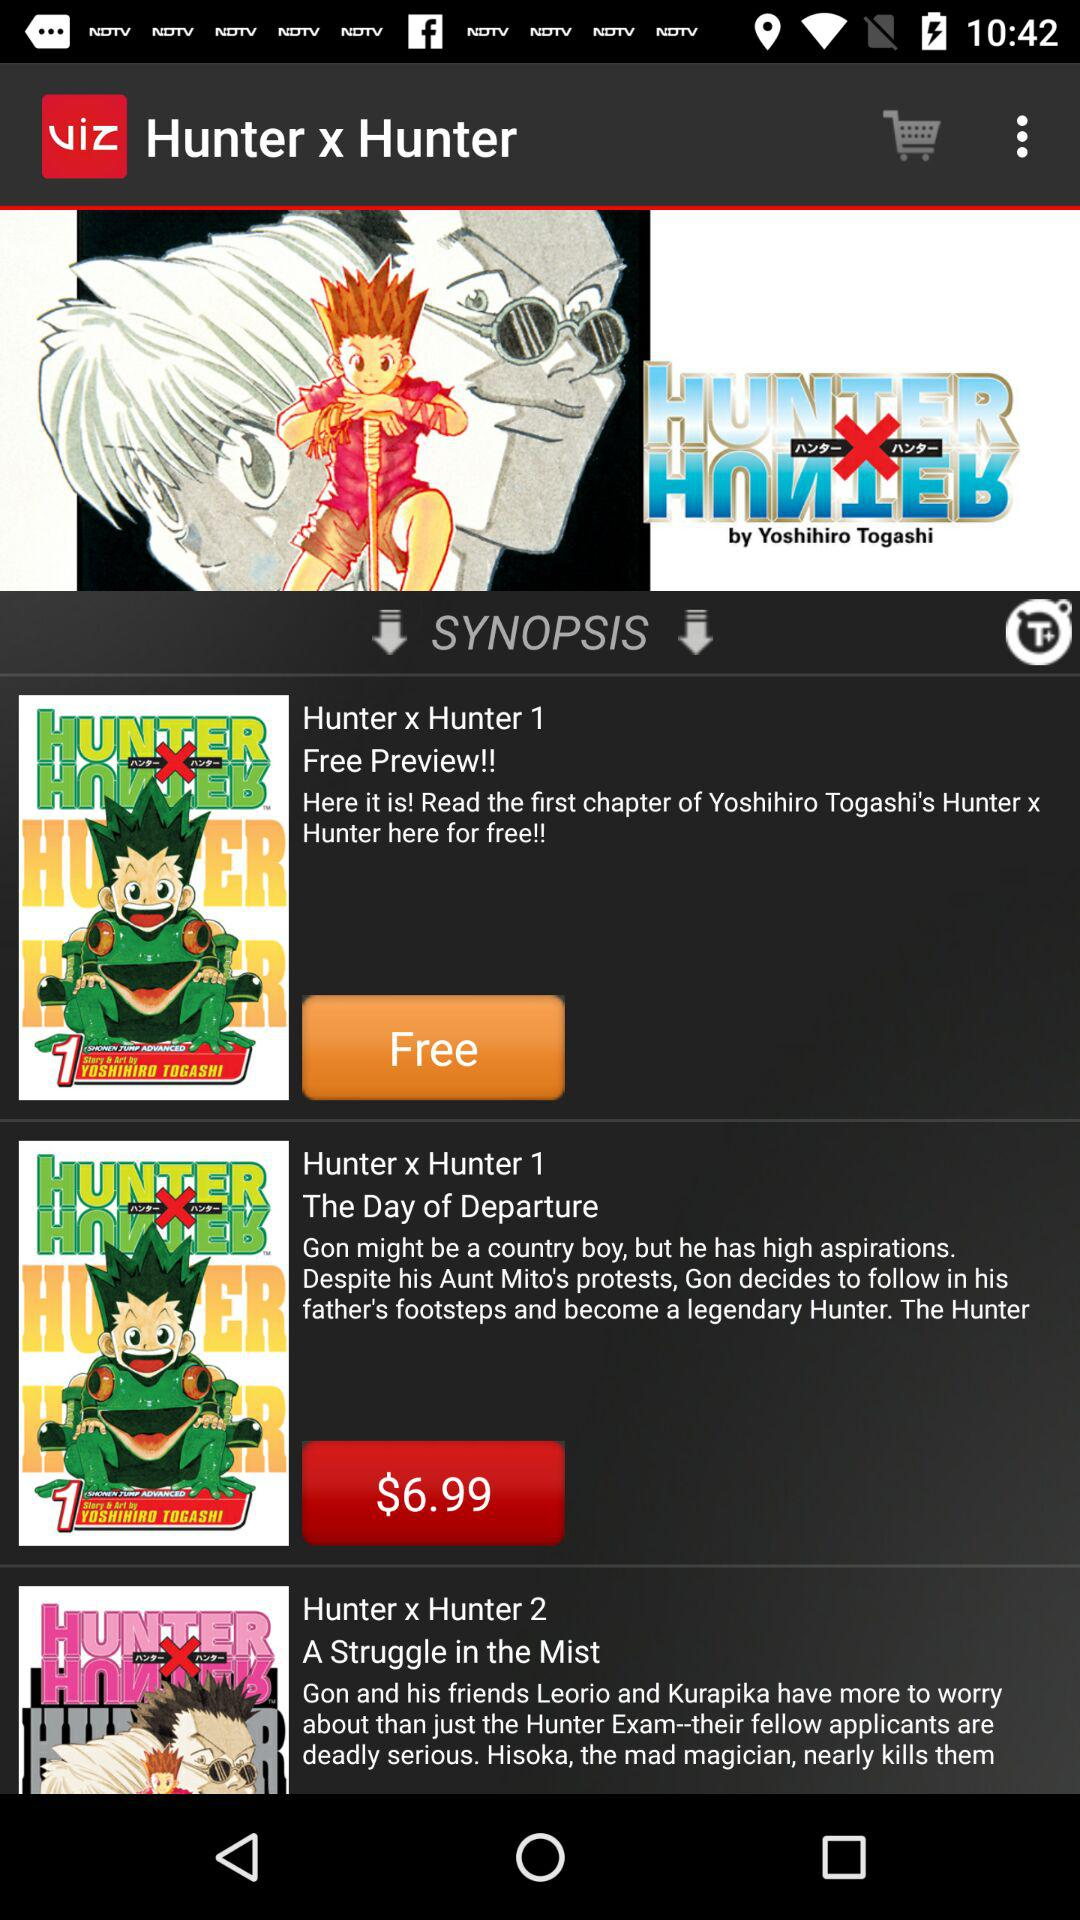What is the cost of the day of departure? The cost of the day of departure is $6.99. 